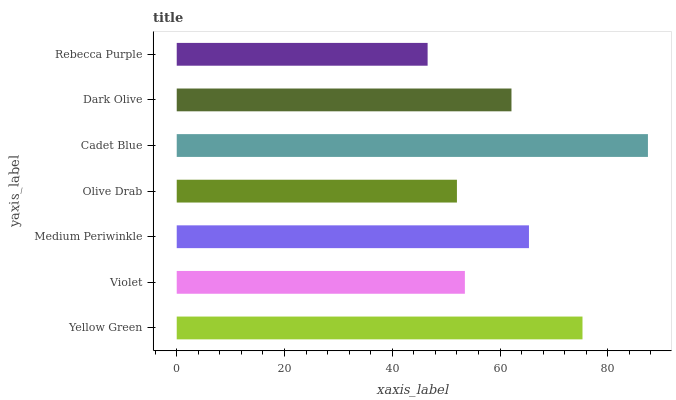Is Rebecca Purple the minimum?
Answer yes or no. Yes. Is Cadet Blue the maximum?
Answer yes or no. Yes. Is Violet the minimum?
Answer yes or no. No. Is Violet the maximum?
Answer yes or no. No. Is Yellow Green greater than Violet?
Answer yes or no. Yes. Is Violet less than Yellow Green?
Answer yes or no. Yes. Is Violet greater than Yellow Green?
Answer yes or no. No. Is Yellow Green less than Violet?
Answer yes or no. No. Is Dark Olive the high median?
Answer yes or no. Yes. Is Dark Olive the low median?
Answer yes or no. Yes. Is Yellow Green the high median?
Answer yes or no. No. Is Medium Periwinkle the low median?
Answer yes or no. No. 